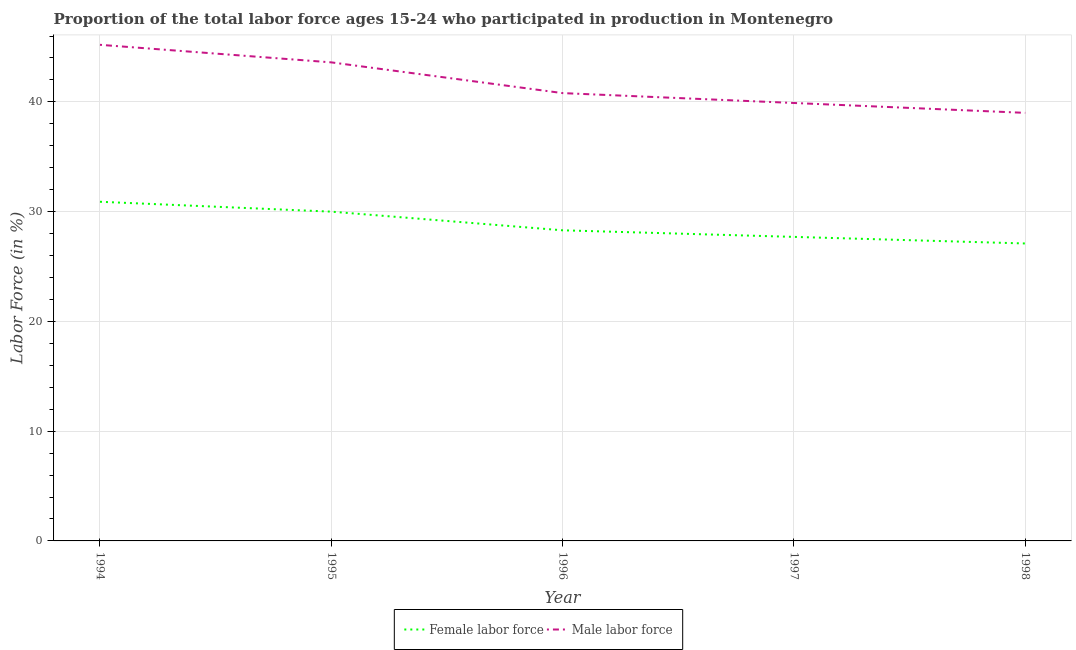Does the line corresponding to percentage of male labour force intersect with the line corresponding to percentage of female labor force?
Make the answer very short. No. Is the number of lines equal to the number of legend labels?
Provide a succinct answer. Yes. What is the percentage of male labour force in 1995?
Ensure brevity in your answer.  43.6. Across all years, what is the maximum percentage of male labour force?
Make the answer very short. 45.2. In which year was the percentage of female labor force maximum?
Your answer should be very brief. 1994. What is the total percentage of male labour force in the graph?
Provide a succinct answer. 208.5. What is the difference between the percentage of female labor force in 1995 and that in 1996?
Keep it short and to the point. 1.7. What is the difference between the percentage of male labour force in 1994 and the percentage of female labor force in 1995?
Offer a terse response. 15.2. What is the average percentage of female labor force per year?
Give a very brief answer. 28.8. In the year 1994, what is the difference between the percentage of female labor force and percentage of male labour force?
Your answer should be very brief. -14.3. What is the ratio of the percentage of male labour force in 1994 to that in 1995?
Make the answer very short. 1.04. Is the difference between the percentage of female labor force in 1997 and 1998 greater than the difference between the percentage of male labour force in 1997 and 1998?
Your response must be concise. No. What is the difference between the highest and the second highest percentage of male labour force?
Keep it short and to the point. 1.6. What is the difference between the highest and the lowest percentage of male labour force?
Your answer should be compact. 6.2. In how many years, is the percentage of male labour force greater than the average percentage of male labour force taken over all years?
Your answer should be very brief. 2. Is the sum of the percentage of female labor force in 1995 and 1997 greater than the maximum percentage of male labour force across all years?
Make the answer very short. Yes. Is the percentage of female labor force strictly less than the percentage of male labour force over the years?
Provide a short and direct response. Yes. How many lines are there?
Ensure brevity in your answer.  2. What is the difference between two consecutive major ticks on the Y-axis?
Provide a succinct answer. 10. Does the graph contain any zero values?
Your response must be concise. No. How are the legend labels stacked?
Ensure brevity in your answer.  Horizontal. What is the title of the graph?
Provide a short and direct response. Proportion of the total labor force ages 15-24 who participated in production in Montenegro. What is the label or title of the X-axis?
Offer a terse response. Year. What is the Labor Force (in %) in Female labor force in 1994?
Your response must be concise. 30.9. What is the Labor Force (in %) of Male labor force in 1994?
Give a very brief answer. 45.2. What is the Labor Force (in %) of Male labor force in 1995?
Your response must be concise. 43.6. What is the Labor Force (in %) of Female labor force in 1996?
Keep it short and to the point. 28.3. What is the Labor Force (in %) of Male labor force in 1996?
Keep it short and to the point. 40.8. What is the Labor Force (in %) of Female labor force in 1997?
Make the answer very short. 27.7. What is the Labor Force (in %) in Male labor force in 1997?
Provide a succinct answer. 39.9. What is the Labor Force (in %) of Female labor force in 1998?
Provide a short and direct response. 27.1. Across all years, what is the maximum Labor Force (in %) in Female labor force?
Your response must be concise. 30.9. Across all years, what is the maximum Labor Force (in %) in Male labor force?
Your answer should be very brief. 45.2. Across all years, what is the minimum Labor Force (in %) in Female labor force?
Make the answer very short. 27.1. What is the total Labor Force (in %) in Female labor force in the graph?
Provide a succinct answer. 144. What is the total Labor Force (in %) of Male labor force in the graph?
Your answer should be compact. 208.5. What is the difference between the Labor Force (in %) of Female labor force in 1994 and that in 1995?
Offer a terse response. 0.9. What is the difference between the Labor Force (in %) in Male labor force in 1994 and that in 1996?
Keep it short and to the point. 4.4. What is the difference between the Labor Force (in %) in Female labor force in 1994 and that in 1997?
Provide a succinct answer. 3.2. What is the difference between the Labor Force (in %) in Female labor force in 1994 and that in 1998?
Your response must be concise. 3.8. What is the difference between the Labor Force (in %) of Female labor force in 1995 and that in 1996?
Keep it short and to the point. 1.7. What is the difference between the Labor Force (in %) of Male labor force in 1995 and that in 1996?
Keep it short and to the point. 2.8. What is the difference between the Labor Force (in %) of Female labor force in 1995 and that in 1997?
Make the answer very short. 2.3. What is the difference between the Labor Force (in %) in Male labor force in 1995 and that in 1998?
Your answer should be compact. 4.6. What is the difference between the Labor Force (in %) of Female labor force in 1996 and that in 1997?
Offer a terse response. 0.6. What is the difference between the Labor Force (in %) in Female labor force in 1996 and that in 1998?
Make the answer very short. 1.2. What is the difference between the Labor Force (in %) in Female labor force in 1994 and the Labor Force (in %) in Male labor force in 1996?
Provide a succinct answer. -9.9. What is the difference between the Labor Force (in %) of Female labor force in 1994 and the Labor Force (in %) of Male labor force in 1997?
Make the answer very short. -9. What is the difference between the Labor Force (in %) of Female labor force in 1995 and the Labor Force (in %) of Male labor force in 1998?
Offer a terse response. -9. What is the difference between the Labor Force (in %) of Female labor force in 1996 and the Labor Force (in %) of Male labor force in 1998?
Your answer should be very brief. -10.7. What is the difference between the Labor Force (in %) in Female labor force in 1997 and the Labor Force (in %) in Male labor force in 1998?
Your answer should be very brief. -11.3. What is the average Labor Force (in %) in Female labor force per year?
Ensure brevity in your answer.  28.8. What is the average Labor Force (in %) in Male labor force per year?
Make the answer very short. 41.7. In the year 1994, what is the difference between the Labor Force (in %) in Female labor force and Labor Force (in %) in Male labor force?
Your answer should be very brief. -14.3. What is the ratio of the Labor Force (in %) of Female labor force in 1994 to that in 1995?
Provide a succinct answer. 1.03. What is the ratio of the Labor Force (in %) of Male labor force in 1994 to that in 1995?
Offer a terse response. 1.04. What is the ratio of the Labor Force (in %) in Female labor force in 1994 to that in 1996?
Provide a short and direct response. 1.09. What is the ratio of the Labor Force (in %) in Male labor force in 1994 to that in 1996?
Offer a very short reply. 1.11. What is the ratio of the Labor Force (in %) of Female labor force in 1994 to that in 1997?
Give a very brief answer. 1.12. What is the ratio of the Labor Force (in %) in Male labor force in 1994 to that in 1997?
Your answer should be compact. 1.13. What is the ratio of the Labor Force (in %) in Female labor force in 1994 to that in 1998?
Your response must be concise. 1.14. What is the ratio of the Labor Force (in %) of Male labor force in 1994 to that in 1998?
Make the answer very short. 1.16. What is the ratio of the Labor Force (in %) in Female labor force in 1995 to that in 1996?
Your answer should be very brief. 1.06. What is the ratio of the Labor Force (in %) of Male labor force in 1995 to that in 1996?
Your response must be concise. 1.07. What is the ratio of the Labor Force (in %) of Female labor force in 1995 to that in 1997?
Offer a terse response. 1.08. What is the ratio of the Labor Force (in %) in Male labor force in 1995 to that in 1997?
Provide a succinct answer. 1.09. What is the ratio of the Labor Force (in %) of Female labor force in 1995 to that in 1998?
Your response must be concise. 1.11. What is the ratio of the Labor Force (in %) of Male labor force in 1995 to that in 1998?
Provide a succinct answer. 1.12. What is the ratio of the Labor Force (in %) of Female labor force in 1996 to that in 1997?
Provide a succinct answer. 1.02. What is the ratio of the Labor Force (in %) of Male labor force in 1996 to that in 1997?
Give a very brief answer. 1.02. What is the ratio of the Labor Force (in %) in Female labor force in 1996 to that in 1998?
Give a very brief answer. 1.04. What is the ratio of the Labor Force (in %) of Male labor force in 1996 to that in 1998?
Give a very brief answer. 1.05. What is the ratio of the Labor Force (in %) in Female labor force in 1997 to that in 1998?
Ensure brevity in your answer.  1.02. What is the ratio of the Labor Force (in %) in Male labor force in 1997 to that in 1998?
Keep it short and to the point. 1.02. What is the difference between the highest and the second highest Labor Force (in %) of Female labor force?
Provide a succinct answer. 0.9. What is the difference between the highest and the second highest Labor Force (in %) of Male labor force?
Keep it short and to the point. 1.6. 